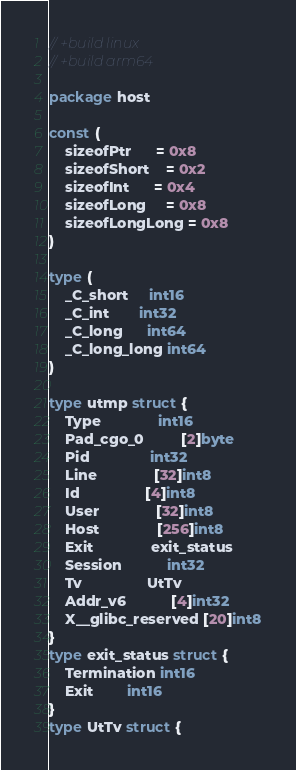<code> <loc_0><loc_0><loc_500><loc_500><_Go_>// +build linux
// +build arm64

package host

const (
	sizeofPtr      = 0x8
	sizeofShort    = 0x2
	sizeofInt      = 0x4
	sizeofLong     = 0x8
	sizeofLongLong = 0x8
)

type (
	_C_short     int16
	_C_int       int32
	_C_long      int64
	_C_long_long int64
)

type utmp struct {
	Type              int16
	Pad_cgo_0         [2]byte
	Pid               int32
	Line              [32]int8
	Id                [4]int8
	User              [32]int8
	Host              [256]int8
	Exit              exit_status
	Session           int32
	Tv                UtTv
	Addr_v6           [4]int32
	X__glibc_reserved [20]int8
}
type exit_status struct {
	Termination int16
	Exit        int16
}
type UtTv struct {</code> 